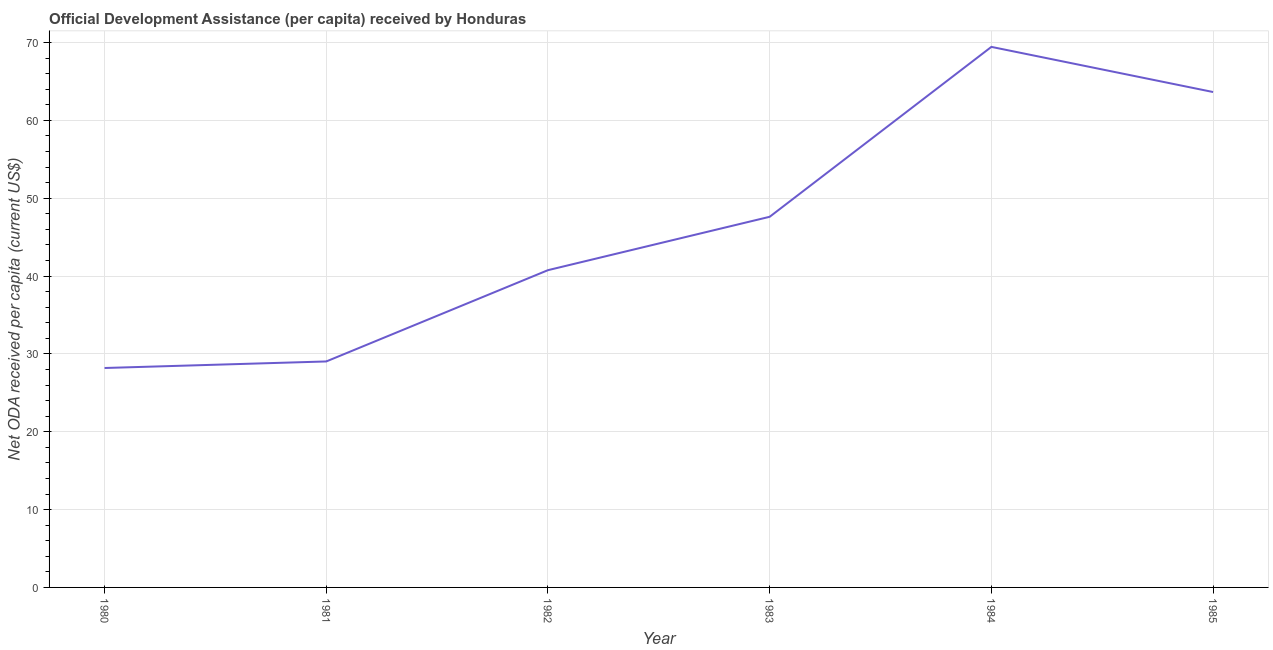What is the net oda received per capita in 1982?
Your answer should be compact. 40.75. Across all years, what is the maximum net oda received per capita?
Your response must be concise. 69.44. Across all years, what is the minimum net oda received per capita?
Your answer should be compact. 28.19. In which year was the net oda received per capita maximum?
Your response must be concise. 1984. In which year was the net oda received per capita minimum?
Your answer should be compact. 1980. What is the sum of the net oda received per capita?
Offer a terse response. 278.65. What is the difference between the net oda received per capita in 1980 and 1984?
Your response must be concise. -41.25. What is the average net oda received per capita per year?
Provide a short and direct response. 46.44. What is the median net oda received per capita?
Give a very brief answer. 44.18. In how many years, is the net oda received per capita greater than 14 US$?
Offer a terse response. 6. What is the ratio of the net oda received per capita in 1982 to that in 1984?
Keep it short and to the point. 0.59. Is the net oda received per capita in 1980 less than that in 1982?
Offer a terse response. Yes. Is the difference between the net oda received per capita in 1981 and 1982 greater than the difference between any two years?
Your response must be concise. No. What is the difference between the highest and the second highest net oda received per capita?
Your response must be concise. 5.8. Is the sum of the net oda received per capita in 1980 and 1985 greater than the maximum net oda received per capita across all years?
Ensure brevity in your answer.  Yes. What is the difference between the highest and the lowest net oda received per capita?
Your response must be concise. 41.25. In how many years, is the net oda received per capita greater than the average net oda received per capita taken over all years?
Give a very brief answer. 3. Does the graph contain any zero values?
Make the answer very short. No. Does the graph contain grids?
Keep it short and to the point. Yes. What is the title of the graph?
Provide a short and direct response. Official Development Assistance (per capita) received by Honduras. What is the label or title of the Y-axis?
Provide a succinct answer. Net ODA received per capita (current US$). What is the Net ODA received per capita (current US$) of 1980?
Your answer should be compact. 28.19. What is the Net ODA received per capita (current US$) in 1981?
Give a very brief answer. 29.03. What is the Net ODA received per capita (current US$) in 1982?
Your answer should be very brief. 40.75. What is the Net ODA received per capita (current US$) in 1983?
Your answer should be very brief. 47.61. What is the Net ODA received per capita (current US$) in 1984?
Offer a very short reply. 69.44. What is the Net ODA received per capita (current US$) of 1985?
Make the answer very short. 63.64. What is the difference between the Net ODA received per capita (current US$) in 1980 and 1981?
Offer a terse response. -0.84. What is the difference between the Net ODA received per capita (current US$) in 1980 and 1982?
Provide a short and direct response. -12.57. What is the difference between the Net ODA received per capita (current US$) in 1980 and 1983?
Ensure brevity in your answer.  -19.43. What is the difference between the Net ODA received per capita (current US$) in 1980 and 1984?
Your answer should be compact. -41.25. What is the difference between the Net ODA received per capita (current US$) in 1980 and 1985?
Your answer should be compact. -35.45. What is the difference between the Net ODA received per capita (current US$) in 1981 and 1982?
Keep it short and to the point. -11.73. What is the difference between the Net ODA received per capita (current US$) in 1981 and 1983?
Make the answer very short. -18.58. What is the difference between the Net ODA received per capita (current US$) in 1981 and 1984?
Ensure brevity in your answer.  -40.41. What is the difference between the Net ODA received per capita (current US$) in 1981 and 1985?
Offer a very short reply. -34.61. What is the difference between the Net ODA received per capita (current US$) in 1982 and 1983?
Ensure brevity in your answer.  -6.86. What is the difference between the Net ODA received per capita (current US$) in 1982 and 1984?
Make the answer very short. -28.68. What is the difference between the Net ODA received per capita (current US$) in 1982 and 1985?
Provide a succinct answer. -22.88. What is the difference between the Net ODA received per capita (current US$) in 1983 and 1984?
Ensure brevity in your answer.  -21.83. What is the difference between the Net ODA received per capita (current US$) in 1983 and 1985?
Your answer should be very brief. -16.03. What is the difference between the Net ODA received per capita (current US$) in 1984 and 1985?
Provide a succinct answer. 5.8. What is the ratio of the Net ODA received per capita (current US$) in 1980 to that in 1982?
Your answer should be compact. 0.69. What is the ratio of the Net ODA received per capita (current US$) in 1980 to that in 1983?
Your response must be concise. 0.59. What is the ratio of the Net ODA received per capita (current US$) in 1980 to that in 1984?
Offer a terse response. 0.41. What is the ratio of the Net ODA received per capita (current US$) in 1980 to that in 1985?
Make the answer very short. 0.44. What is the ratio of the Net ODA received per capita (current US$) in 1981 to that in 1982?
Your answer should be compact. 0.71. What is the ratio of the Net ODA received per capita (current US$) in 1981 to that in 1983?
Your answer should be very brief. 0.61. What is the ratio of the Net ODA received per capita (current US$) in 1981 to that in 1984?
Ensure brevity in your answer.  0.42. What is the ratio of the Net ODA received per capita (current US$) in 1981 to that in 1985?
Offer a very short reply. 0.46. What is the ratio of the Net ODA received per capita (current US$) in 1982 to that in 1983?
Provide a succinct answer. 0.86. What is the ratio of the Net ODA received per capita (current US$) in 1982 to that in 1984?
Give a very brief answer. 0.59. What is the ratio of the Net ODA received per capita (current US$) in 1982 to that in 1985?
Make the answer very short. 0.64. What is the ratio of the Net ODA received per capita (current US$) in 1983 to that in 1984?
Make the answer very short. 0.69. What is the ratio of the Net ODA received per capita (current US$) in 1983 to that in 1985?
Make the answer very short. 0.75. What is the ratio of the Net ODA received per capita (current US$) in 1984 to that in 1985?
Your answer should be compact. 1.09. 